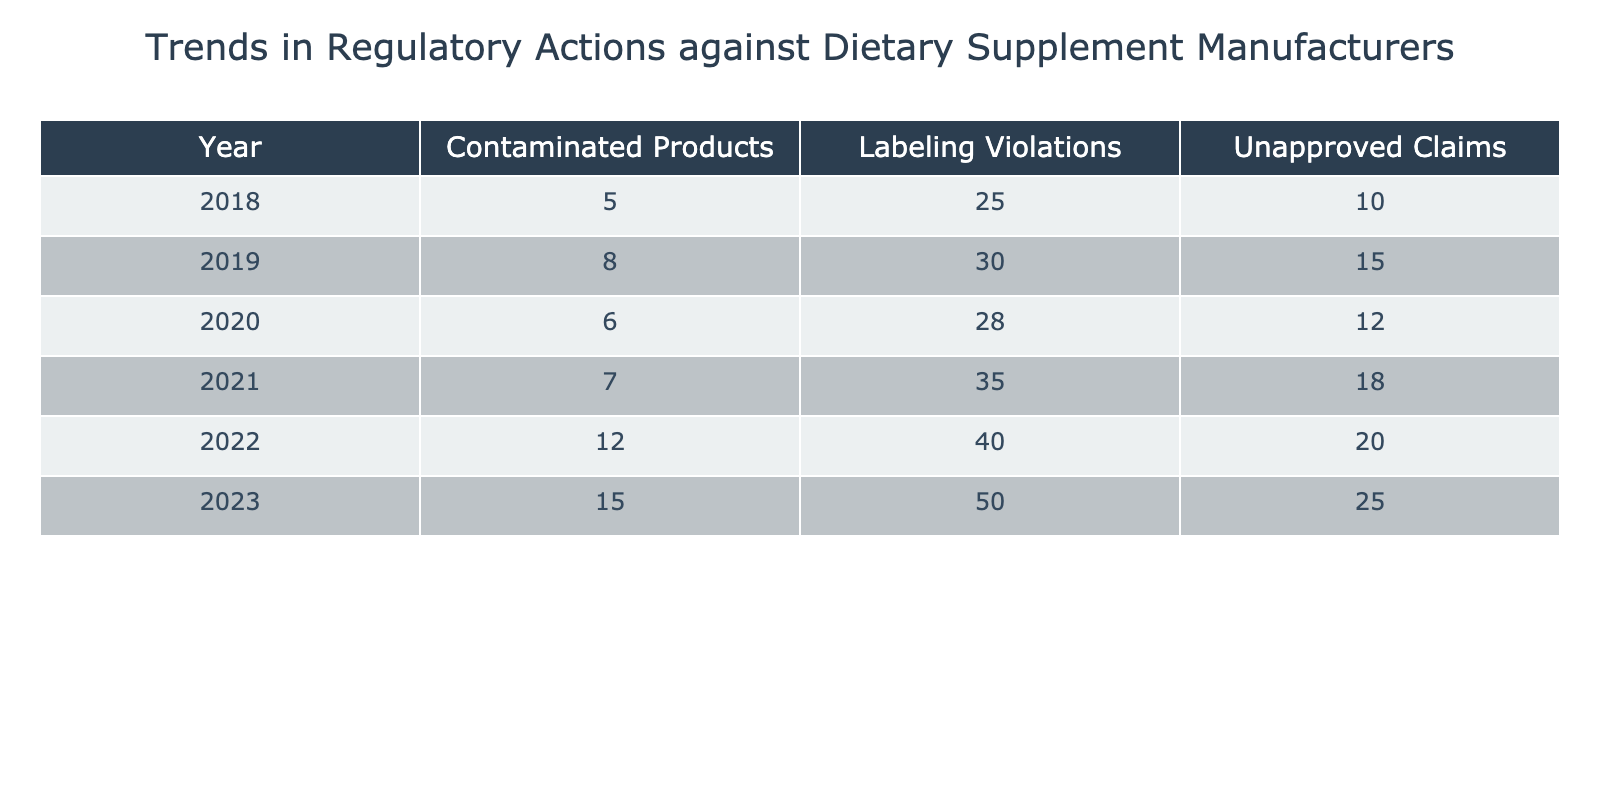What was the count of labeling violations in 2021? By referencing the row for the year 2021 in the table, we can see that the count for labeling violations is 35.
Answer: 35 Which year had the highest number of unapproved claims? Looking through the "Unapproved Claims" column, we find that the year 2023 had the highest count of 25.
Answer: 2023 What is the total number of contaminated products reported over all the years? To find the total, we add the counts from each year: 5 (2018) + 8 (2019) + 6 (2020) + 7 (2021) + 12 (2022) + 15 (2023) = 53.
Answer: 53 Were there more labeling violations in 2022 than in 2018? In 2022, there were 40 labeling violations and in 2018, there were 25. Since 40 is greater than 25, the statement is true.
Answer: Yes What was the increase in unapproved claims from 2020 to 2021? The count of unapproved claims in 2020 was 12, and in 2021 it was 18. The increase can be calculated as 18 - 12 = 6.
Answer: 6 In which year was the difference between labeling violations and contaminated products the greatest? Calculate the difference for each year: 2018 (25 - 5 = 20), 2019 (30 - 8 = 22), 2020 (28 - 6 = 22), 2021 (35 - 7 = 28), 2022 (40 - 12 = 28), and 2023 (50 - 15 = 35). The greatest difference occurs in 2023 with a difference of 35.
Answer: 2023 How many unapproved claims were recorded in 2020? Checking the count of unapproved claims specifically for the year 2020, we find that it was 12.
Answer: 12 Is it true that more than 50 contaminated products were reported across all years combined? Summing the contaminated products gives us 53 (as calculated earlier), which is more than 50. The statement is true.
Answer: Yes What is the average number of labeling violations from 2018 to 2023? To find the average, we need to total the labeling violations for those years: 25 + 30 + 28 + 35 + 40 + 50 = 208. There are 6 years, so the average is 208 / 6 = 34.67.
Answer: 34.67 